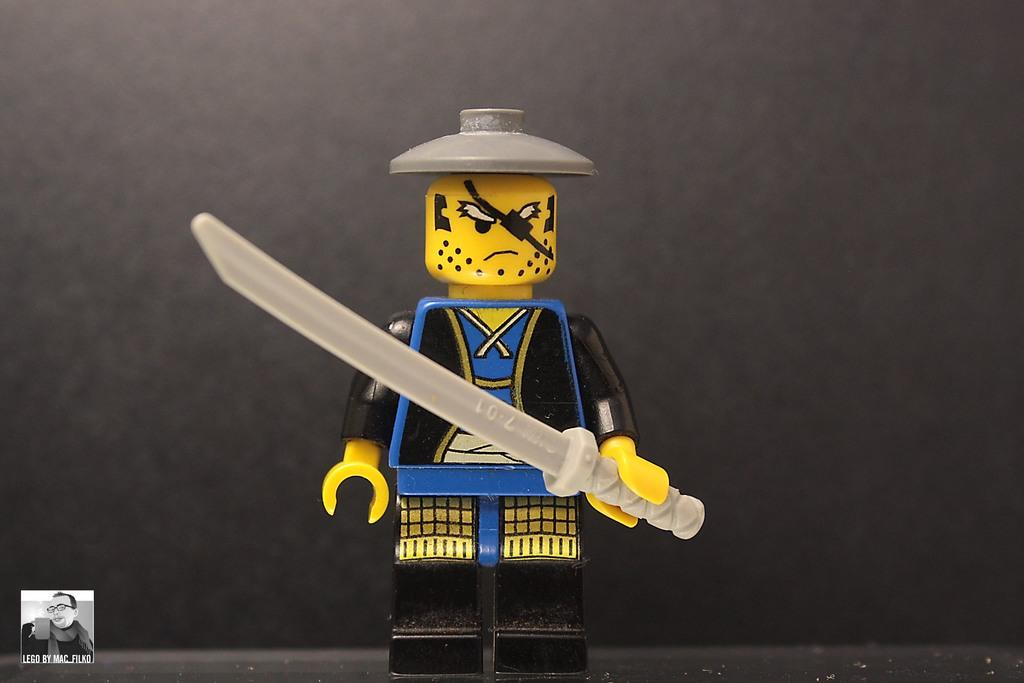What object can be seen in the image? There is a toy in the image. What colors are present on the toy? The toy has blue, yellow, and black colors. What is the toy holding in its hand? The toy is holding an ash-colored knife. What color is the background of the image? The background of the image is black. Where is the toad sitting in the image? There is no toad present in the image. What type of board is being used by the toy in the image? The toy is not using any board in the image. 